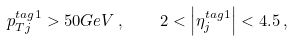<formula> <loc_0><loc_0><loc_500><loc_500>p _ { T j } ^ { t a g 1 } > 5 0 G e V \, , \quad 2 < \left | \eta _ { j } ^ { t a g 1 } \right | < 4 . 5 \, ,</formula> 